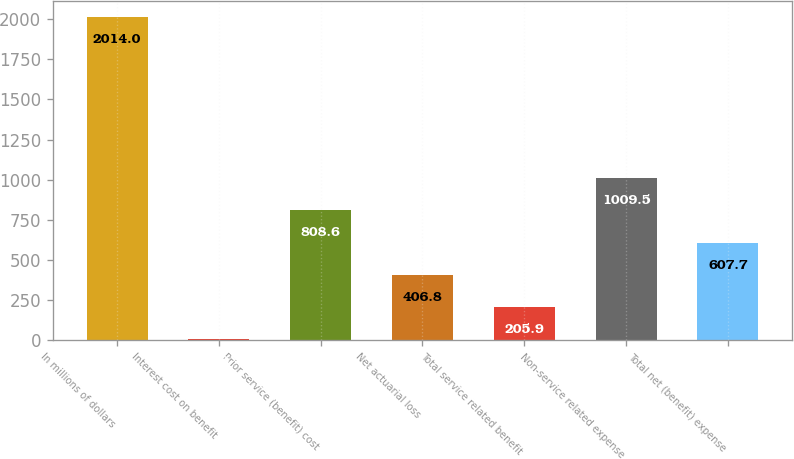<chart> <loc_0><loc_0><loc_500><loc_500><bar_chart><fcel>In millions of dollars<fcel>Interest cost on benefit<fcel>Prior service (benefit) cost<fcel>Net actuarial loss<fcel>Total service related benefit<fcel>Non-service related expense<fcel>Total net (benefit) expense<nl><fcel>2014<fcel>5<fcel>808.6<fcel>406.8<fcel>205.9<fcel>1009.5<fcel>607.7<nl></chart> 